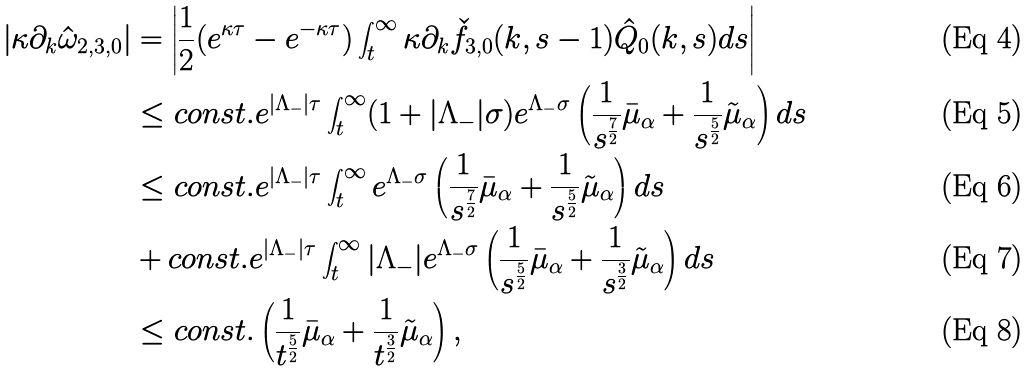Convert formula to latex. <formula><loc_0><loc_0><loc_500><loc_500>\left | \kappa \partial _ { k } \hat { \omega } _ { 2 , 3 , 0 } \right | & = \left | \frac { 1 } { 2 } ( e ^ { \kappa \tau } - e ^ { - \kappa \tau } ) \int _ { t } ^ { \infty } \kappa \partial _ { k } \check { f } _ { 3 , 0 } ( k , s - 1 ) \hat { Q } _ { 0 } ( k , s ) d s \right | \\ & \leq c o n s t . e ^ { | \Lambda _ { - } | \tau } \int _ { t } ^ { \infty } ( 1 + | \Lambda _ { - } | \sigma ) e ^ { \Lambda _ { - } \sigma } \left ( \frac { 1 } { s ^ { \frac { 7 } { 2 } } } \bar { \mu } _ { \alpha } + \frac { 1 } { s ^ { \frac { 5 } { 2 } } } \tilde { \mu } _ { \alpha } \right ) d s \\ & \leq c o n s t . e ^ { | \Lambda _ { - } | \tau } \int _ { t } ^ { \infty } e ^ { \Lambda _ { - } \sigma } \left ( \frac { 1 } { s ^ { \frac { 7 } { 2 } } } \bar { \mu } _ { \alpha } + \frac { 1 } { s ^ { \frac { 5 } { 2 } } } \tilde { \mu } _ { \alpha } \right ) d s \\ & + c o n s t . e ^ { | \Lambda _ { - } | \tau } \int _ { t } ^ { \infty } | \Lambda _ { - } | e ^ { \Lambda _ { - } \sigma } \left ( \frac { 1 } { s ^ { \frac { 5 } { 2 } } } \bar { \mu } _ { \alpha } + \frac { 1 } { s ^ { \frac { 3 } { 2 } } } \tilde { \mu } _ { \alpha } \right ) d s \\ & \leq c o n s t . \left ( \frac { 1 } { t ^ { \frac { 5 } { 2 } } } \bar { \mu } _ { \alpha } + \frac { 1 } { t ^ { \frac { 3 } { 2 } } } \tilde { \mu } _ { \alpha } \right ) ,</formula> 